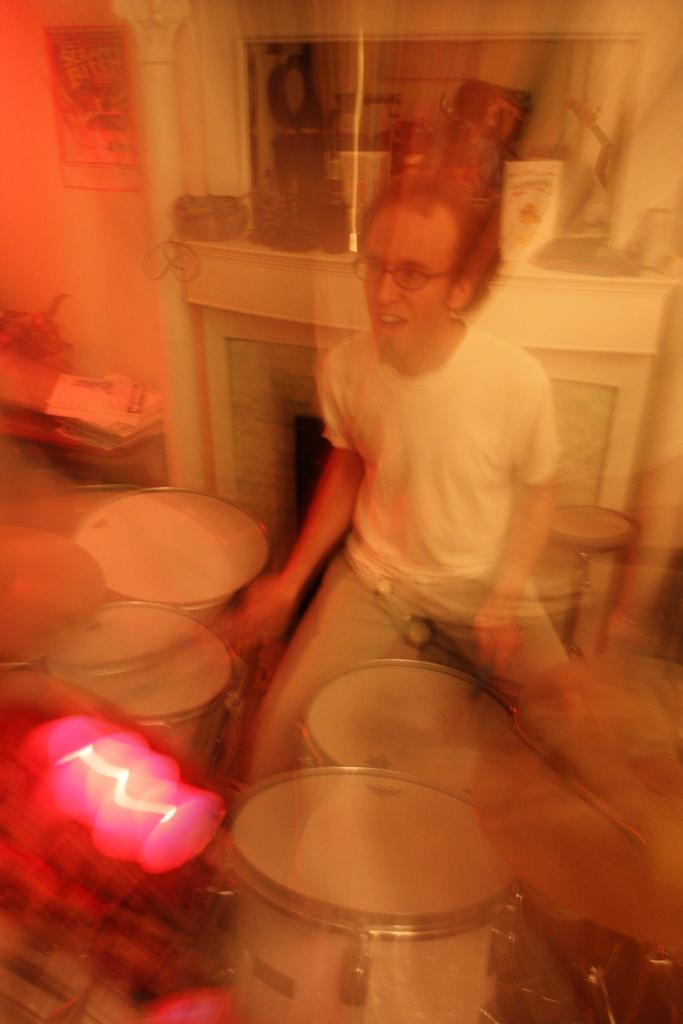What is the man in the image doing? The man is playing drums. What is the man sitting on while playing drums? The man is sitting on a stool. What can be seen in the background of the image? There is a shelf in the background of the image. What is placed on the shelf? There are items placed on the shelf. What type of spade is the man using to play the drums in the image? There is no spade present in the image; the man is using drumsticks to play the drums. 